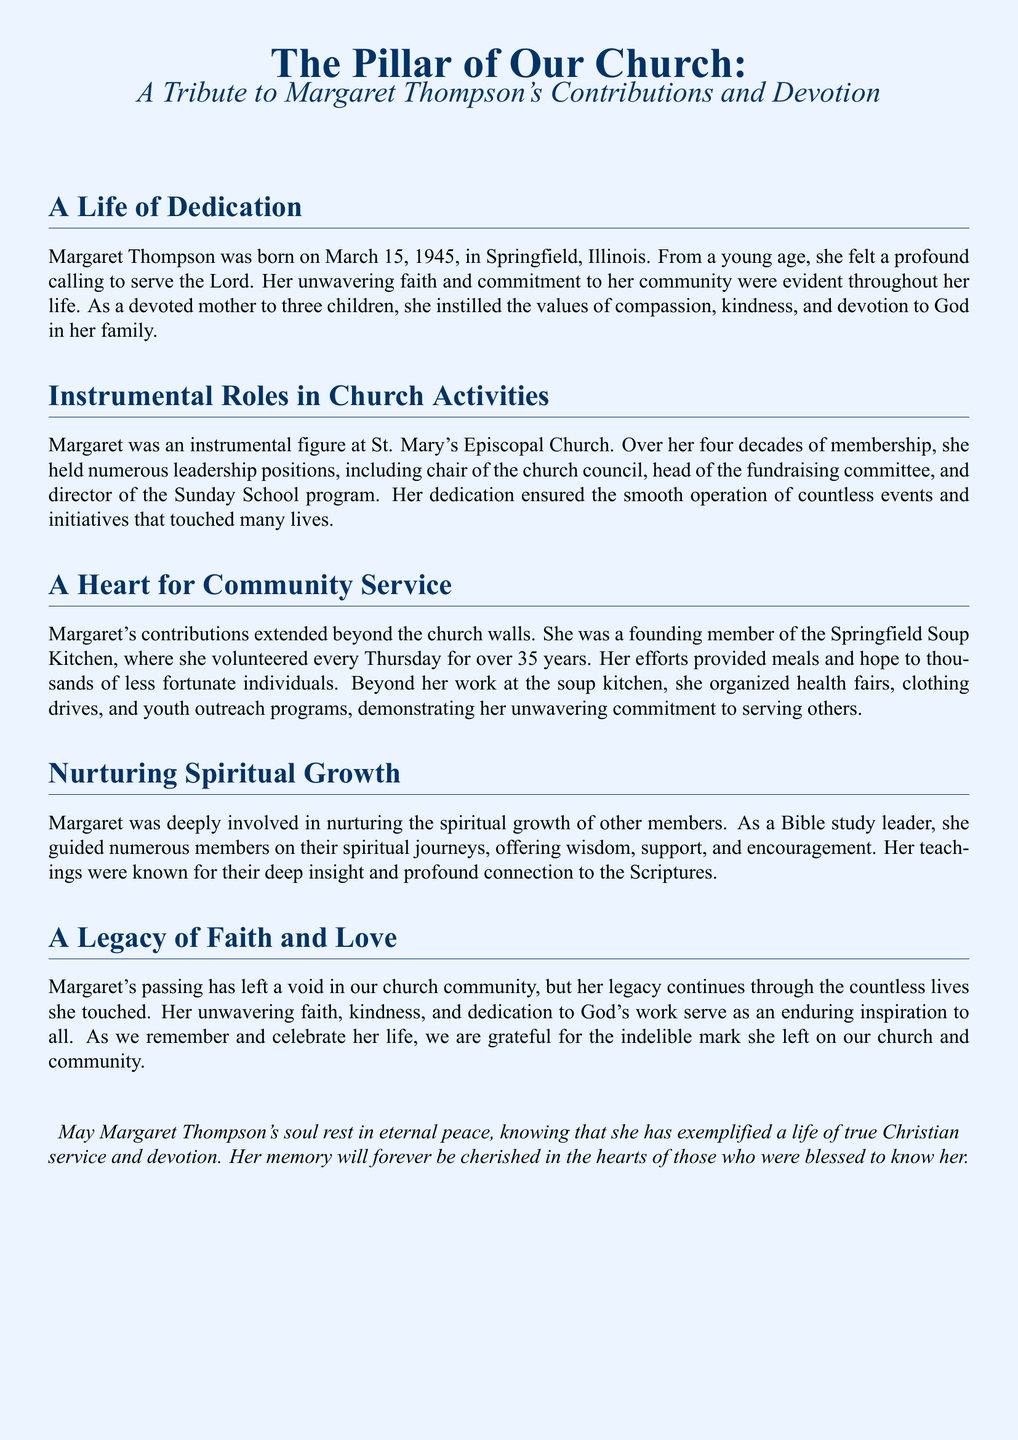What is the name of the person being honored in the obituary? The obituary is a tribute to Margaret Thompson's contributions and devotion.
Answer: Margaret Thompson What was Margaret Thompson's birth date? The document states that Margaret Thompson was born on March 15, 1945.
Answer: March 15, 1945 How many children did Margaret have? The text indicates that she was a devoted mother to three children.
Answer: three What role did Margaret hold concerning the Sunday School program? Margaret was the director of the Sunday School program at St. Mary's Episcopal Church.
Answer: director For how many years did Margaret volunteer at the Springfield Soup Kitchen? The document mentions she volunteered every Thursday for over 35 years.
Answer: over 35 years What was one of the community initiatives Margaret organized? The text highlights several initiatives, one of which was clothing drives.
Answer: clothing drives In what setting did Margaret nurture the spiritual growth of others? The document indicates she was a Bible study leader, guiding members on their spiritual journeys.
Answer: Bible study leader What is said to be Margaret's enduring impact on the community? The text states that her unwavering faith, kindness, and dedication serve as an inspiration to all.
Answer: inspiration to all 